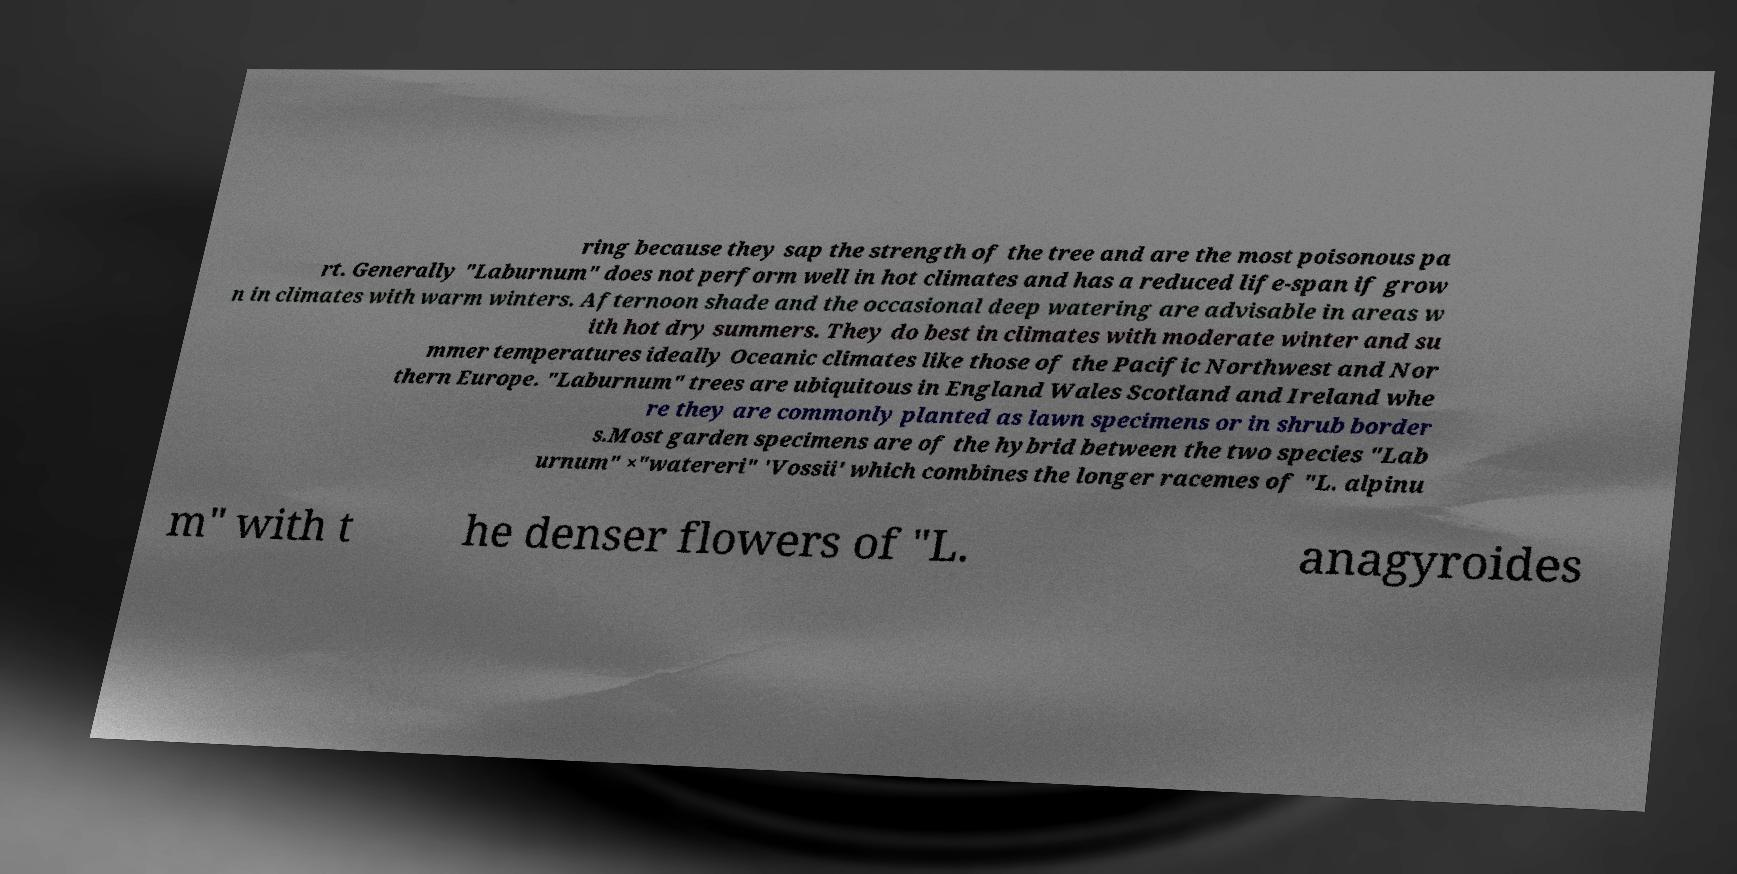I need the written content from this picture converted into text. Can you do that? ring because they sap the strength of the tree and are the most poisonous pa rt. Generally "Laburnum" does not perform well in hot climates and has a reduced life-span if grow n in climates with warm winters. Afternoon shade and the occasional deep watering are advisable in areas w ith hot dry summers. They do best in climates with moderate winter and su mmer temperatures ideally Oceanic climates like those of the Pacific Northwest and Nor thern Europe. "Laburnum" trees are ubiquitous in England Wales Scotland and Ireland whe re they are commonly planted as lawn specimens or in shrub border s.Most garden specimens are of the hybrid between the two species "Lab urnum" ×"watereri" 'Vossii' which combines the longer racemes of "L. alpinu m" with t he denser flowers of "L. anagyroides 